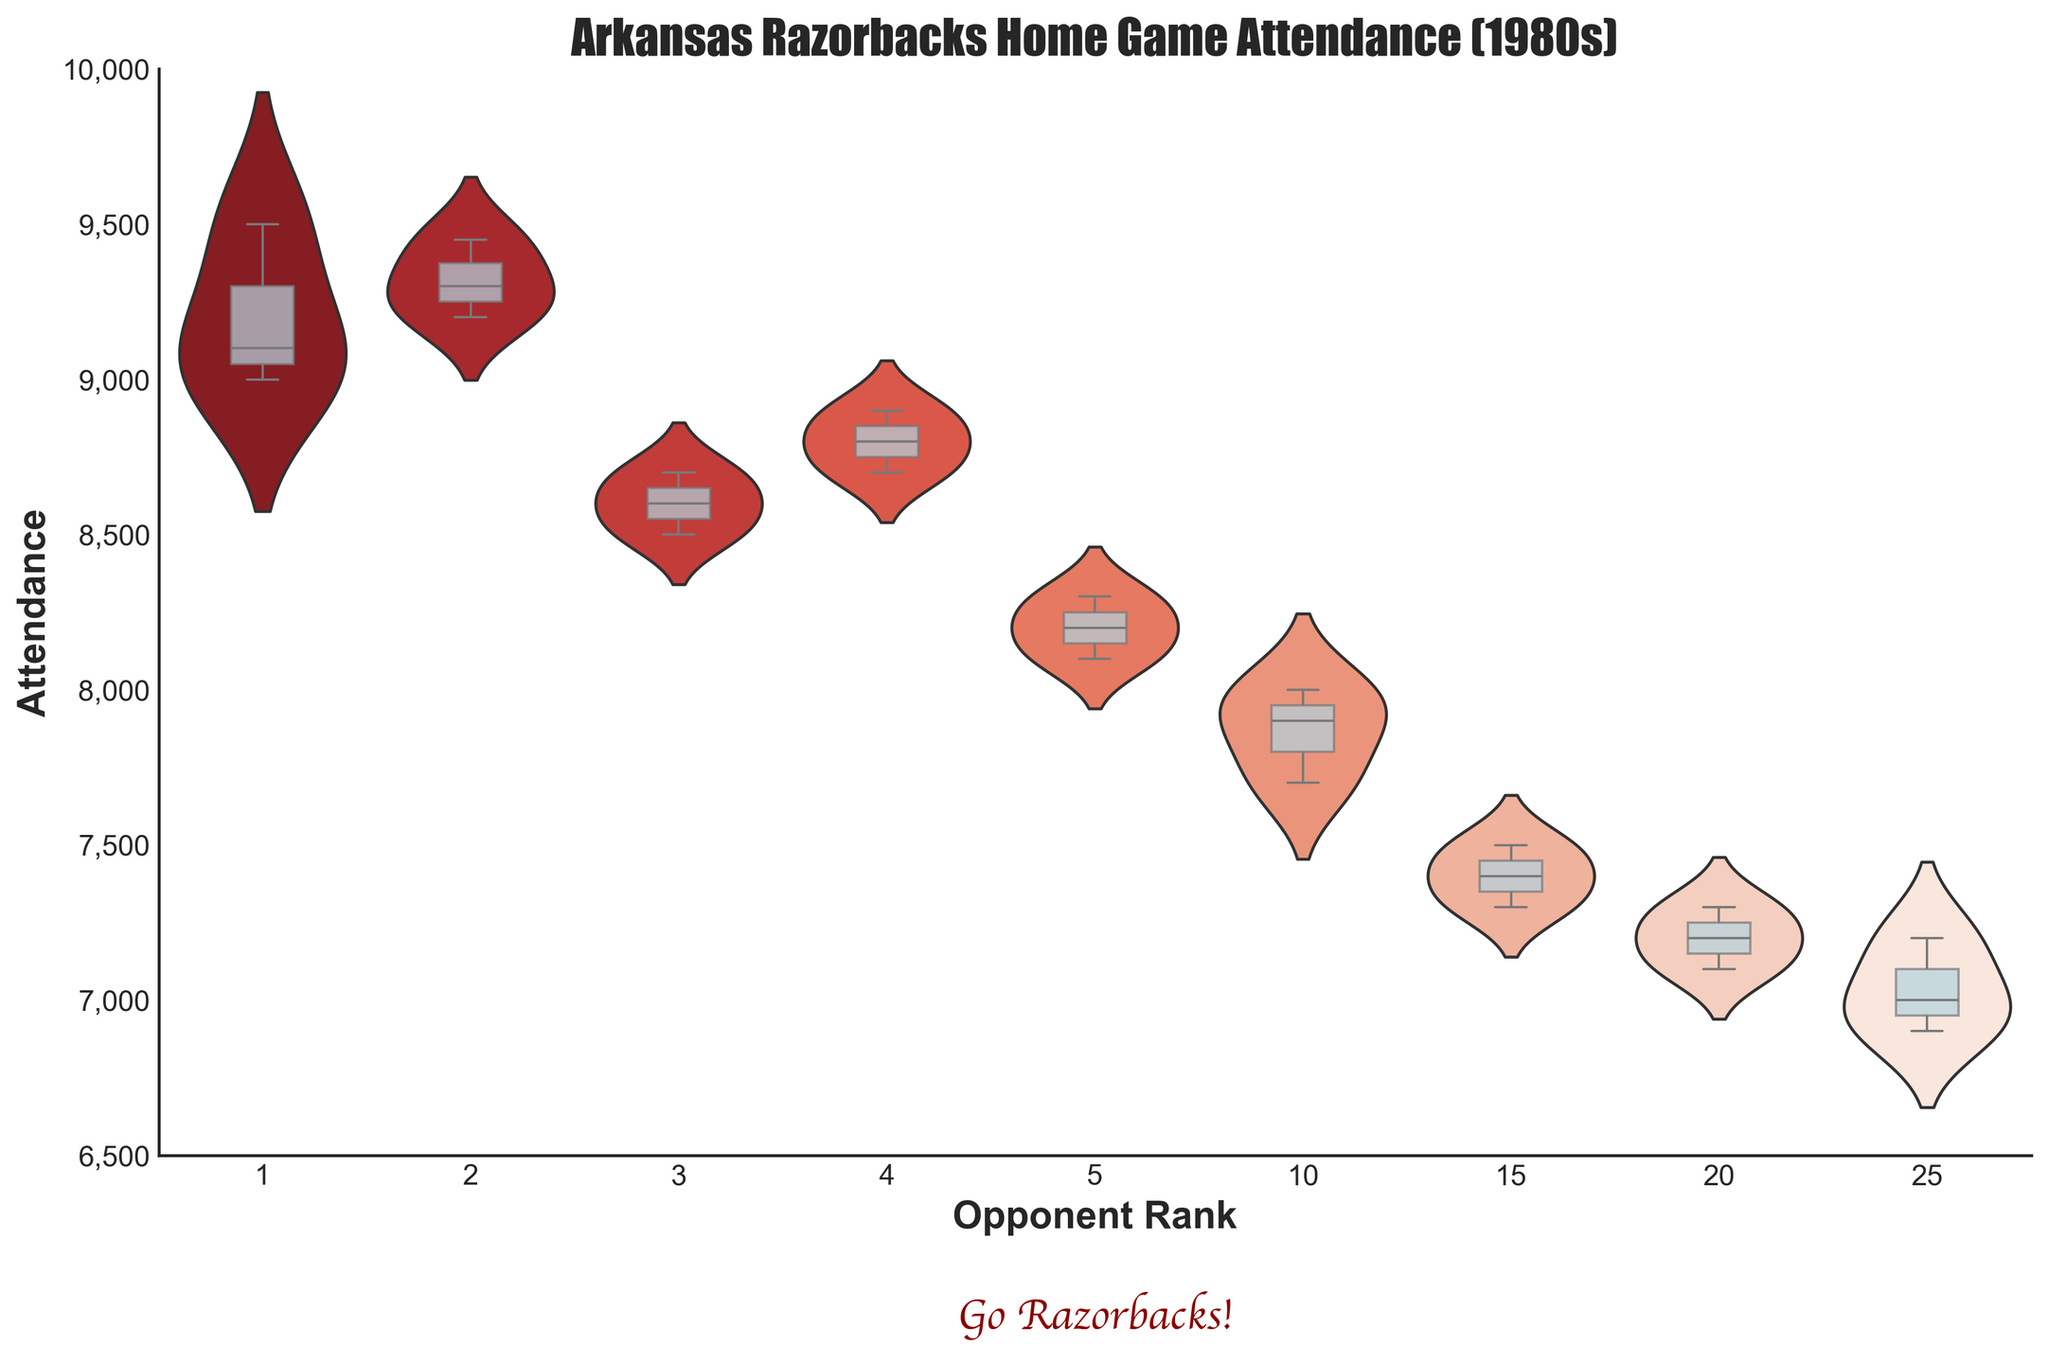What is the title of the figure? The title is written at the top of the figure. It reads "Arkansas Razorbacks Home Game Attendance (1980s)".
Answer: Arkansas Razorbacks Home Game Attendance (1980s) What is the highest attendance value displayed in the figure? By looking across the y-axis and examining the overall distribution, the highest attendance value can be seen around 9500.
Answer: 9500 Which opponent rank had the widest distribution of attendance? The width of the violin plot indicates the distribution spread; rank 1 has the widest plot, signifying the largest variability in attendance.
Answer: 1 What is the median attendance for opponent rank 15? The box plot overlay shows the median value as the horizontal line within the box. For opponent rank 15, this line falls around 7400.
Answer: 7400 Does opponent rank 10 have a higher median attendance than rank 25? By comparing the median lines of the two ranks, it is clear that rank 10 has a higher median attendance than rank 25, which is below 7200.
Answer: Yes What is the range of attendance for opponent rank 5? The range is found by subtracting the minimum value from the maximum. For rank 5, the maximum is around 8300 and the minimum is around 8100, so the range is 8300 - 8100 = 200.
Answer: 200 Which opponent rank draws the least average attendance? By comparing the centers of the box plots, rank 25 has the lowest average (mean) attendance because its box is centered lower on the y-axis than the others.
Answer: 25 Does the figure indicate any correlation between opponent rank and attendance? By observing the trend in the plots, higher-ranked opponents (lower rank numbers) generally attract higher attendances, indicating a negative correlation between rank number and attendance.
Answer: Yes What is the interquartile range (IQR) of attendance for opponent rank 3? The IQR is the length of the box in the box plot. For rank 3, the distance between the first quartile (around 8600) and third quartile (around 8700) is approximately 100.
Answer: 100 Which opponent rank had the most consistent attendance? The narrowest violin plot suggests the most consistent attendance. Rank 20 has the most consistent values, as indicated by its thin plot.
Answer: 20 